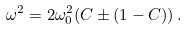<formula> <loc_0><loc_0><loc_500><loc_500>\omega ^ { 2 } = 2 \omega _ { 0 } ^ { 2 } ( C \pm ( 1 - C ) ) \, .</formula> 